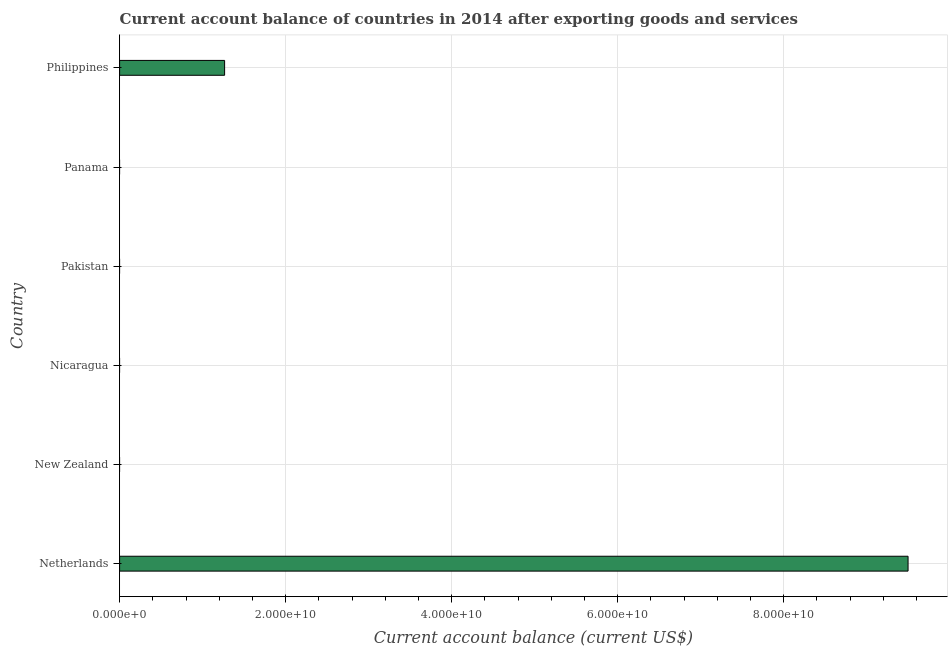What is the title of the graph?
Your answer should be very brief. Current account balance of countries in 2014 after exporting goods and services. What is the label or title of the X-axis?
Provide a short and direct response. Current account balance (current US$). What is the label or title of the Y-axis?
Offer a terse response. Country. Across all countries, what is the maximum current account balance?
Provide a succinct answer. 9.50e+1. Across all countries, what is the minimum current account balance?
Make the answer very short. 0. What is the sum of the current account balance?
Provide a succinct answer. 1.08e+11. What is the average current account balance per country?
Your response must be concise. 1.79e+1. What is the median current account balance?
Give a very brief answer. 0. In how many countries, is the current account balance greater than 12000000000 US$?
Your answer should be very brief. 2. What is the ratio of the current account balance in Netherlands to that in Philippines?
Offer a very short reply. 7.51. What is the difference between the highest and the lowest current account balance?
Make the answer very short. 9.50e+1. In how many countries, is the current account balance greater than the average current account balance taken over all countries?
Offer a terse response. 1. Are all the bars in the graph horizontal?
Provide a short and direct response. Yes. How many countries are there in the graph?
Your response must be concise. 6. Are the values on the major ticks of X-axis written in scientific E-notation?
Your response must be concise. Yes. What is the Current account balance (current US$) in Netherlands?
Your answer should be compact. 9.50e+1. What is the Current account balance (current US$) in Nicaragua?
Your answer should be compact. 0. What is the Current account balance (current US$) in Panama?
Your answer should be compact. 0. What is the Current account balance (current US$) in Philippines?
Make the answer very short. 1.27e+1. What is the difference between the Current account balance (current US$) in Netherlands and Philippines?
Offer a terse response. 8.23e+1. What is the ratio of the Current account balance (current US$) in Netherlands to that in Philippines?
Your response must be concise. 7.51. 